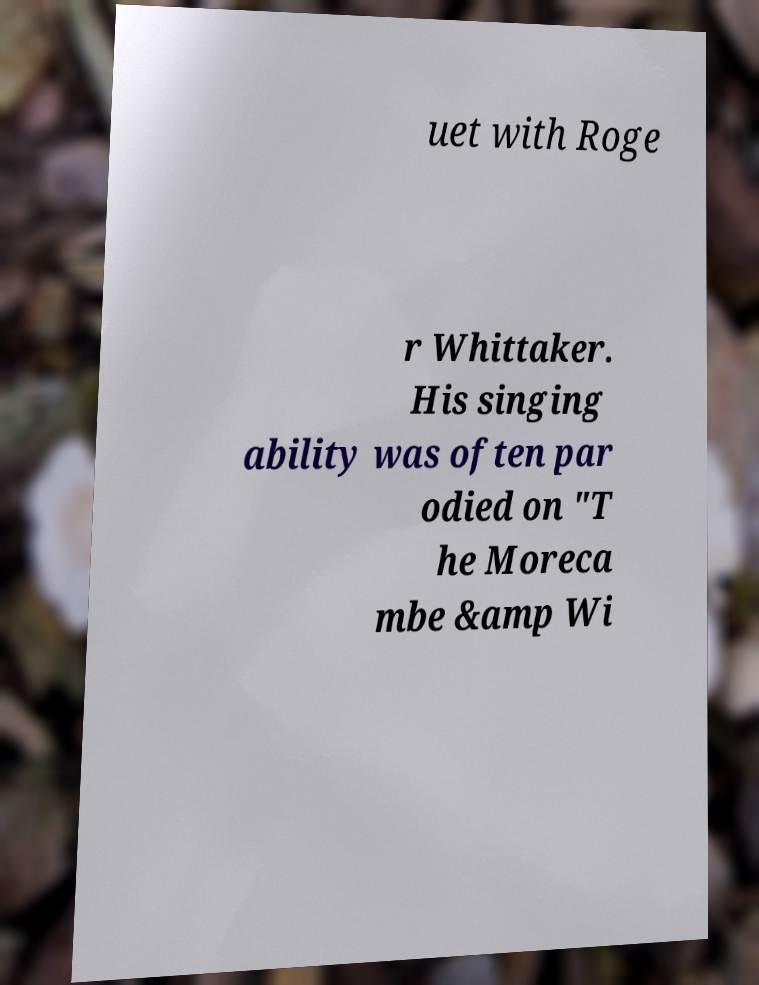Could you assist in decoding the text presented in this image and type it out clearly? uet with Roge r Whittaker. His singing ability was often par odied on "T he Moreca mbe &amp Wi 